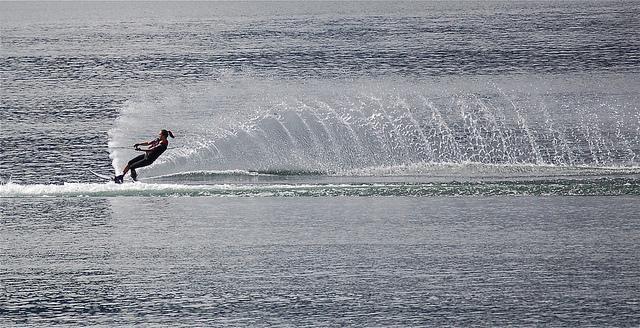How many boats can be seen in this image?
Give a very brief answer. 0. 